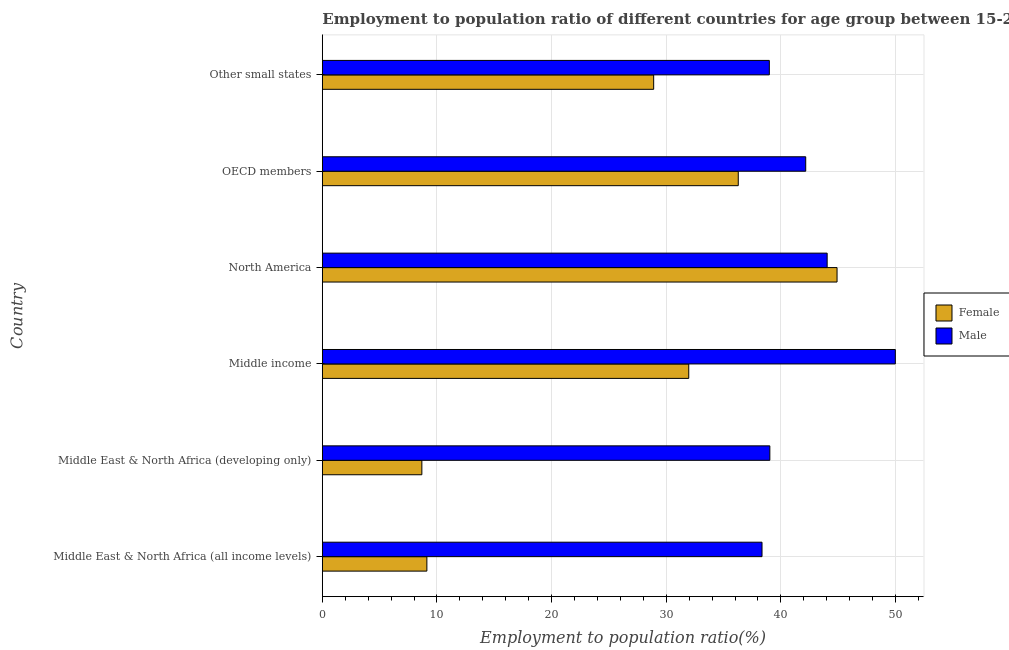How many groups of bars are there?
Give a very brief answer. 6. Are the number of bars per tick equal to the number of legend labels?
Your answer should be compact. Yes. Are the number of bars on each tick of the Y-axis equal?
Your answer should be very brief. Yes. How many bars are there on the 1st tick from the top?
Provide a succinct answer. 2. What is the label of the 6th group of bars from the top?
Your response must be concise. Middle East & North Africa (all income levels). In how many cases, is the number of bars for a given country not equal to the number of legend labels?
Keep it short and to the point. 0. What is the employment to population ratio(male) in Other small states?
Offer a very short reply. 39. Across all countries, what is the maximum employment to population ratio(male)?
Your answer should be compact. 49.99. Across all countries, what is the minimum employment to population ratio(male)?
Your answer should be very brief. 38.36. In which country was the employment to population ratio(female) minimum?
Ensure brevity in your answer.  Middle East & North Africa (developing only). What is the total employment to population ratio(female) in the graph?
Make the answer very short. 159.86. What is the difference between the employment to population ratio(female) in Middle income and that in OECD members?
Offer a terse response. -4.32. What is the difference between the employment to population ratio(female) in Middle East & North Africa (all income levels) and the employment to population ratio(male) in Other small states?
Offer a terse response. -29.88. What is the average employment to population ratio(male) per country?
Provide a short and direct response. 42.1. What is the difference between the employment to population ratio(male) and employment to population ratio(female) in Middle East & North Africa (all income levels)?
Give a very brief answer. 29.24. In how many countries, is the employment to population ratio(female) greater than 50 %?
Give a very brief answer. 0. What is the ratio of the employment to population ratio(male) in Middle East & North Africa (all income levels) to that in OECD members?
Keep it short and to the point. 0.91. What is the difference between the highest and the second highest employment to population ratio(male)?
Provide a succinct answer. 5.95. What is the difference between the highest and the lowest employment to population ratio(female)?
Your answer should be compact. 36.22. In how many countries, is the employment to population ratio(female) greater than the average employment to population ratio(female) taken over all countries?
Make the answer very short. 4. How many bars are there?
Your answer should be compact. 12. Are all the bars in the graph horizontal?
Keep it short and to the point. Yes. How many countries are there in the graph?
Ensure brevity in your answer.  6. Are the values on the major ticks of X-axis written in scientific E-notation?
Provide a short and direct response. No. Where does the legend appear in the graph?
Ensure brevity in your answer.  Center right. How many legend labels are there?
Offer a very short reply. 2. How are the legend labels stacked?
Keep it short and to the point. Vertical. What is the title of the graph?
Offer a terse response. Employment to population ratio of different countries for age group between 15-24 years. What is the label or title of the Y-axis?
Your response must be concise. Country. What is the Employment to population ratio(%) in Female in Middle East & North Africa (all income levels)?
Make the answer very short. 9.12. What is the Employment to population ratio(%) in Male in Middle East & North Africa (all income levels)?
Your answer should be very brief. 38.36. What is the Employment to population ratio(%) of Female in Middle East & North Africa (developing only)?
Ensure brevity in your answer.  8.68. What is the Employment to population ratio(%) in Male in Middle East & North Africa (developing only)?
Make the answer very short. 39.04. What is the Employment to population ratio(%) of Female in Middle income?
Offer a very short reply. 31.97. What is the Employment to population ratio(%) of Male in Middle income?
Make the answer very short. 49.99. What is the Employment to population ratio(%) in Female in North America?
Ensure brevity in your answer.  44.9. What is the Employment to population ratio(%) in Male in North America?
Your answer should be compact. 44.04. What is the Employment to population ratio(%) in Female in OECD members?
Offer a terse response. 36.29. What is the Employment to population ratio(%) of Male in OECD members?
Provide a succinct answer. 42.17. What is the Employment to population ratio(%) of Female in Other small states?
Ensure brevity in your answer.  28.9. What is the Employment to population ratio(%) of Male in Other small states?
Your response must be concise. 39. Across all countries, what is the maximum Employment to population ratio(%) of Female?
Your answer should be compact. 44.9. Across all countries, what is the maximum Employment to population ratio(%) of Male?
Ensure brevity in your answer.  49.99. Across all countries, what is the minimum Employment to population ratio(%) in Female?
Offer a very short reply. 8.68. Across all countries, what is the minimum Employment to population ratio(%) in Male?
Your answer should be very brief. 38.36. What is the total Employment to population ratio(%) in Female in the graph?
Your response must be concise. 159.86. What is the total Employment to population ratio(%) in Male in the graph?
Ensure brevity in your answer.  252.59. What is the difference between the Employment to population ratio(%) of Female in Middle East & North Africa (all income levels) and that in Middle East & North Africa (developing only)?
Give a very brief answer. 0.44. What is the difference between the Employment to population ratio(%) in Male in Middle East & North Africa (all income levels) and that in Middle East & North Africa (developing only)?
Provide a short and direct response. -0.68. What is the difference between the Employment to population ratio(%) of Female in Middle East & North Africa (all income levels) and that in Middle income?
Your answer should be very brief. -22.85. What is the difference between the Employment to population ratio(%) in Male in Middle East & North Africa (all income levels) and that in Middle income?
Ensure brevity in your answer.  -11.63. What is the difference between the Employment to population ratio(%) in Female in Middle East & North Africa (all income levels) and that in North America?
Your answer should be very brief. -35.78. What is the difference between the Employment to population ratio(%) in Male in Middle East & North Africa (all income levels) and that in North America?
Provide a succinct answer. -5.68. What is the difference between the Employment to population ratio(%) of Female in Middle East & North Africa (all income levels) and that in OECD members?
Make the answer very short. -27.16. What is the difference between the Employment to population ratio(%) of Male in Middle East & North Africa (all income levels) and that in OECD members?
Give a very brief answer. -3.81. What is the difference between the Employment to population ratio(%) of Female in Middle East & North Africa (all income levels) and that in Other small states?
Your answer should be very brief. -19.78. What is the difference between the Employment to population ratio(%) of Male in Middle East & North Africa (all income levels) and that in Other small states?
Make the answer very short. -0.64. What is the difference between the Employment to population ratio(%) in Female in Middle East & North Africa (developing only) and that in Middle income?
Ensure brevity in your answer.  -23.28. What is the difference between the Employment to population ratio(%) in Male in Middle East & North Africa (developing only) and that in Middle income?
Provide a short and direct response. -10.95. What is the difference between the Employment to population ratio(%) of Female in Middle East & North Africa (developing only) and that in North America?
Provide a short and direct response. -36.22. What is the difference between the Employment to population ratio(%) in Male in Middle East & North Africa (developing only) and that in North America?
Keep it short and to the point. -5. What is the difference between the Employment to population ratio(%) of Female in Middle East & North Africa (developing only) and that in OECD members?
Offer a terse response. -27.6. What is the difference between the Employment to population ratio(%) of Male in Middle East & North Africa (developing only) and that in OECD members?
Offer a terse response. -3.13. What is the difference between the Employment to population ratio(%) of Female in Middle East & North Africa (developing only) and that in Other small states?
Your response must be concise. -20.22. What is the difference between the Employment to population ratio(%) of Male in Middle East & North Africa (developing only) and that in Other small states?
Your answer should be very brief. 0.04. What is the difference between the Employment to population ratio(%) in Female in Middle income and that in North America?
Ensure brevity in your answer.  -12.94. What is the difference between the Employment to population ratio(%) of Male in Middle income and that in North America?
Your response must be concise. 5.95. What is the difference between the Employment to population ratio(%) in Female in Middle income and that in OECD members?
Your response must be concise. -4.32. What is the difference between the Employment to population ratio(%) in Male in Middle income and that in OECD members?
Make the answer very short. 7.82. What is the difference between the Employment to population ratio(%) of Female in Middle income and that in Other small states?
Make the answer very short. 3.06. What is the difference between the Employment to population ratio(%) in Male in Middle income and that in Other small states?
Ensure brevity in your answer.  10.99. What is the difference between the Employment to population ratio(%) in Female in North America and that in OECD members?
Provide a short and direct response. 8.62. What is the difference between the Employment to population ratio(%) in Male in North America and that in OECD members?
Provide a succinct answer. 1.87. What is the difference between the Employment to population ratio(%) of Female in North America and that in Other small states?
Provide a succinct answer. 16. What is the difference between the Employment to population ratio(%) of Male in North America and that in Other small states?
Keep it short and to the point. 5.04. What is the difference between the Employment to population ratio(%) in Female in OECD members and that in Other small states?
Keep it short and to the point. 7.38. What is the difference between the Employment to population ratio(%) in Male in OECD members and that in Other small states?
Ensure brevity in your answer.  3.17. What is the difference between the Employment to population ratio(%) of Female in Middle East & North Africa (all income levels) and the Employment to population ratio(%) of Male in Middle East & North Africa (developing only)?
Provide a short and direct response. -29.92. What is the difference between the Employment to population ratio(%) in Female in Middle East & North Africa (all income levels) and the Employment to population ratio(%) in Male in Middle income?
Give a very brief answer. -40.87. What is the difference between the Employment to population ratio(%) of Female in Middle East & North Africa (all income levels) and the Employment to population ratio(%) of Male in North America?
Offer a very short reply. -34.92. What is the difference between the Employment to population ratio(%) in Female in Middle East & North Africa (all income levels) and the Employment to population ratio(%) in Male in OECD members?
Your answer should be compact. -33.05. What is the difference between the Employment to population ratio(%) in Female in Middle East & North Africa (all income levels) and the Employment to population ratio(%) in Male in Other small states?
Ensure brevity in your answer.  -29.88. What is the difference between the Employment to population ratio(%) of Female in Middle East & North Africa (developing only) and the Employment to population ratio(%) of Male in Middle income?
Ensure brevity in your answer.  -41.3. What is the difference between the Employment to population ratio(%) in Female in Middle East & North Africa (developing only) and the Employment to population ratio(%) in Male in North America?
Keep it short and to the point. -35.36. What is the difference between the Employment to population ratio(%) in Female in Middle East & North Africa (developing only) and the Employment to population ratio(%) in Male in OECD members?
Your answer should be very brief. -33.49. What is the difference between the Employment to population ratio(%) in Female in Middle East & North Africa (developing only) and the Employment to population ratio(%) in Male in Other small states?
Make the answer very short. -30.31. What is the difference between the Employment to population ratio(%) of Female in Middle income and the Employment to population ratio(%) of Male in North America?
Ensure brevity in your answer.  -12.07. What is the difference between the Employment to population ratio(%) in Female in Middle income and the Employment to population ratio(%) in Male in OECD members?
Offer a very short reply. -10.2. What is the difference between the Employment to population ratio(%) in Female in Middle income and the Employment to population ratio(%) in Male in Other small states?
Ensure brevity in your answer.  -7.03. What is the difference between the Employment to population ratio(%) of Female in North America and the Employment to population ratio(%) of Male in OECD members?
Offer a very short reply. 2.73. What is the difference between the Employment to population ratio(%) of Female in North America and the Employment to population ratio(%) of Male in Other small states?
Make the answer very short. 5.91. What is the difference between the Employment to population ratio(%) of Female in OECD members and the Employment to population ratio(%) of Male in Other small states?
Your answer should be compact. -2.71. What is the average Employment to population ratio(%) of Female per country?
Provide a succinct answer. 26.64. What is the average Employment to population ratio(%) of Male per country?
Your response must be concise. 42.1. What is the difference between the Employment to population ratio(%) in Female and Employment to population ratio(%) in Male in Middle East & North Africa (all income levels)?
Your answer should be very brief. -29.24. What is the difference between the Employment to population ratio(%) of Female and Employment to population ratio(%) of Male in Middle East & North Africa (developing only)?
Ensure brevity in your answer.  -30.36. What is the difference between the Employment to population ratio(%) in Female and Employment to population ratio(%) in Male in Middle income?
Ensure brevity in your answer.  -18.02. What is the difference between the Employment to population ratio(%) in Female and Employment to population ratio(%) in Male in North America?
Your answer should be compact. 0.86. What is the difference between the Employment to population ratio(%) in Female and Employment to population ratio(%) in Male in OECD members?
Offer a terse response. -5.88. What is the difference between the Employment to population ratio(%) of Female and Employment to population ratio(%) of Male in Other small states?
Give a very brief answer. -10.09. What is the ratio of the Employment to population ratio(%) in Female in Middle East & North Africa (all income levels) to that in Middle East & North Africa (developing only)?
Offer a terse response. 1.05. What is the ratio of the Employment to population ratio(%) of Male in Middle East & North Africa (all income levels) to that in Middle East & North Africa (developing only)?
Give a very brief answer. 0.98. What is the ratio of the Employment to population ratio(%) of Female in Middle East & North Africa (all income levels) to that in Middle income?
Ensure brevity in your answer.  0.29. What is the ratio of the Employment to population ratio(%) of Male in Middle East & North Africa (all income levels) to that in Middle income?
Offer a terse response. 0.77. What is the ratio of the Employment to population ratio(%) in Female in Middle East & North Africa (all income levels) to that in North America?
Provide a succinct answer. 0.2. What is the ratio of the Employment to population ratio(%) in Male in Middle East & North Africa (all income levels) to that in North America?
Offer a terse response. 0.87. What is the ratio of the Employment to population ratio(%) of Female in Middle East & North Africa (all income levels) to that in OECD members?
Keep it short and to the point. 0.25. What is the ratio of the Employment to population ratio(%) of Male in Middle East & North Africa (all income levels) to that in OECD members?
Provide a succinct answer. 0.91. What is the ratio of the Employment to population ratio(%) in Female in Middle East & North Africa (all income levels) to that in Other small states?
Provide a short and direct response. 0.32. What is the ratio of the Employment to population ratio(%) in Male in Middle East & North Africa (all income levels) to that in Other small states?
Make the answer very short. 0.98. What is the ratio of the Employment to population ratio(%) in Female in Middle East & North Africa (developing only) to that in Middle income?
Your response must be concise. 0.27. What is the ratio of the Employment to population ratio(%) of Male in Middle East & North Africa (developing only) to that in Middle income?
Your answer should be compact. 0.78. What is the ratio of the Employment to population ratio(%) in Female in Middle East & North Africa (developing only) to that in North America?
Give a very brief answer. 0.19. What is the ratio of the Employment to population ratio(%) in Male in Middle East & North Africa (developing only) to that in North America?
Your answer should be very brief. 0.89. What is the ratio of the Employment to population ratio(%) of Female in Middle East & North Africa (developing only) to that in OECD members?
Provide a short and direct response. 0.24. What is the ratio of the Employment to population ratio(%) in Male in Middle East & North Africa (developing only) to that in OECD members?
Make the answer very short. 0.93. What is the ratio of the Employment to population ratio(%) of Female in Middle East & North Africa (developing only) to that in Other small states?
Your answer should be compact. 0.3. What is the ratio of the Employment to population ratio(%) in Male in Middle East & North Africa (developing only) to that in Other small states?
Your answer should be compact. 1. What is the ratio of the Employment to population ratio(%) in Female in Middle income to that in North America?
Your answer should be compact. 0.71. What is the ratio of the Employment to population ratio(%) of Male in Middle income to that in North America?
Ensure brevity in your answer.  1.14. What is the ratio of the Employment to population ratio(%) in Female in Middle income to that in OECD members?
Give a very brief answer. 0.88. What is the ratio of the Employment to population ratio(%) of Male in Middle income to that in OECD members?
Keep it short and to the point. 1.19. What is the ratio of the Employment to population ratio(%) in Female in Middle income to that in Other small states?
Offer a terse response. 1.11. What is the ratio of the Employment to population ratio(%) of Male in Middle income to that in Other small states?
Keep it short and to the point. 1.28. What is the ratio of the Employment to population ratio(%) in Female in North America to that in OECD members?
Offer a very short reply. 1.24. What is the ratio of the Employment to population ratio(%) of Male in North America to that in OECD members?
Your answer should be compact. 1.04. What is the ratio of the Employment to population ratio(%) in Female in North America to that in Other small states?
Keep it short and to the point. 1.55. What is the ratio of the Employment to population ratio(%) of Male in North America to that in Other small states?
Ensure brevity in your answer.  1.13. What is the ratio of the Employment to population ratio(%) in Female in OECD members to that in Other small states?
Your response must be concise. 1.26. What is the ratio of the Employment to population ratio(%) of Male in OECD members to that in Other small states?
Your response must be concise. 1.08. What is the difference between the highest and the second highest Employment to population ratio(%) of Female?
Provide a short and direct response. 8.62. What is the difference between the highest and the second highest Employment to population ratio(%) in Male?
Ensure brevity in your answer.  5.95. What is the difference between the highest and the lowest Employment to population ratio(%) in Female?
Your response must be concise. 36.22. What is the difference between the highest and the lowest Employment to population ratio(%) in Male?
Give a very brief answer. 11.63. 